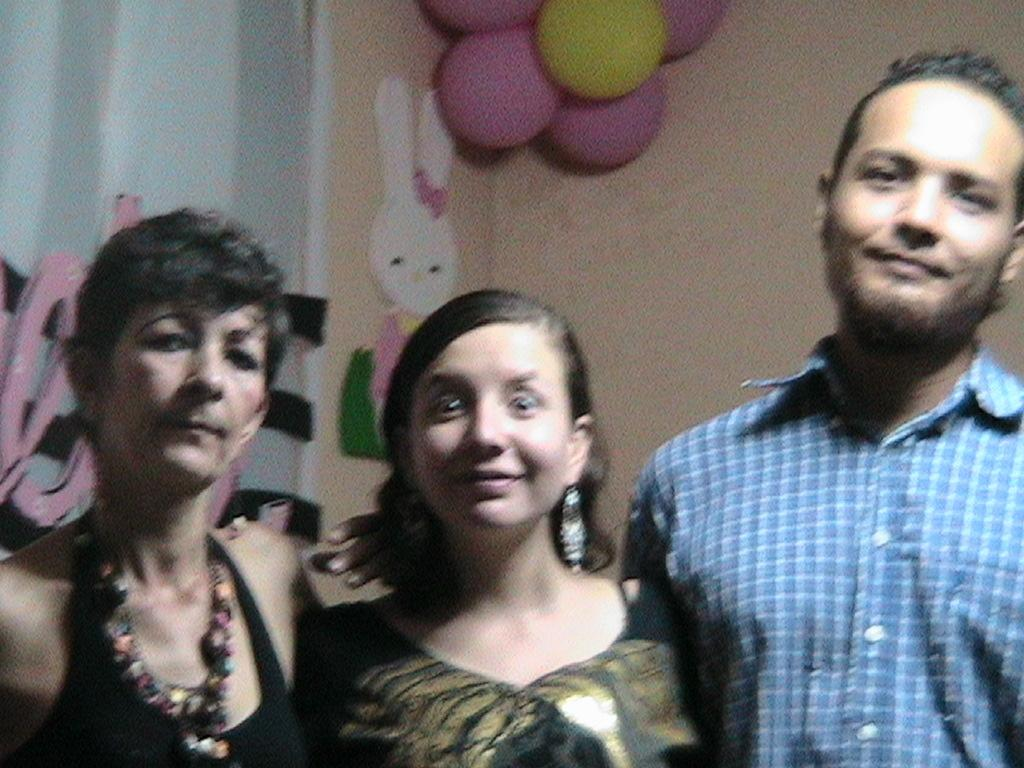How many people are in the image? There are two women and a man standing in the image. What can be seen in the background of the image? There is a wall in the background of the image. What is on the wall? Balloons and a toy poster are present on the wall. What else can be seen in the image? There is a curtain in the image. What type of town is depicted in the image? There is no town depicted in the image; it features two women, a man, a wall with balloons and a toy poster, and a curtain. 